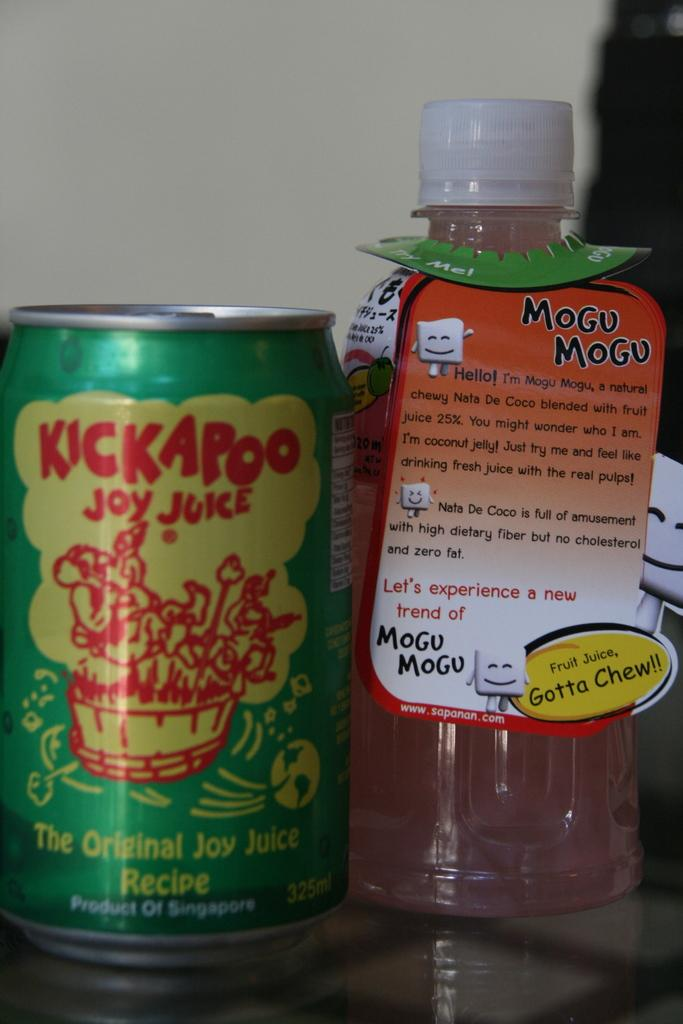<image>
Create a compact narrative representing the image presented. A can of Kickaroo is next to a bottle of Mogu Mogu. 